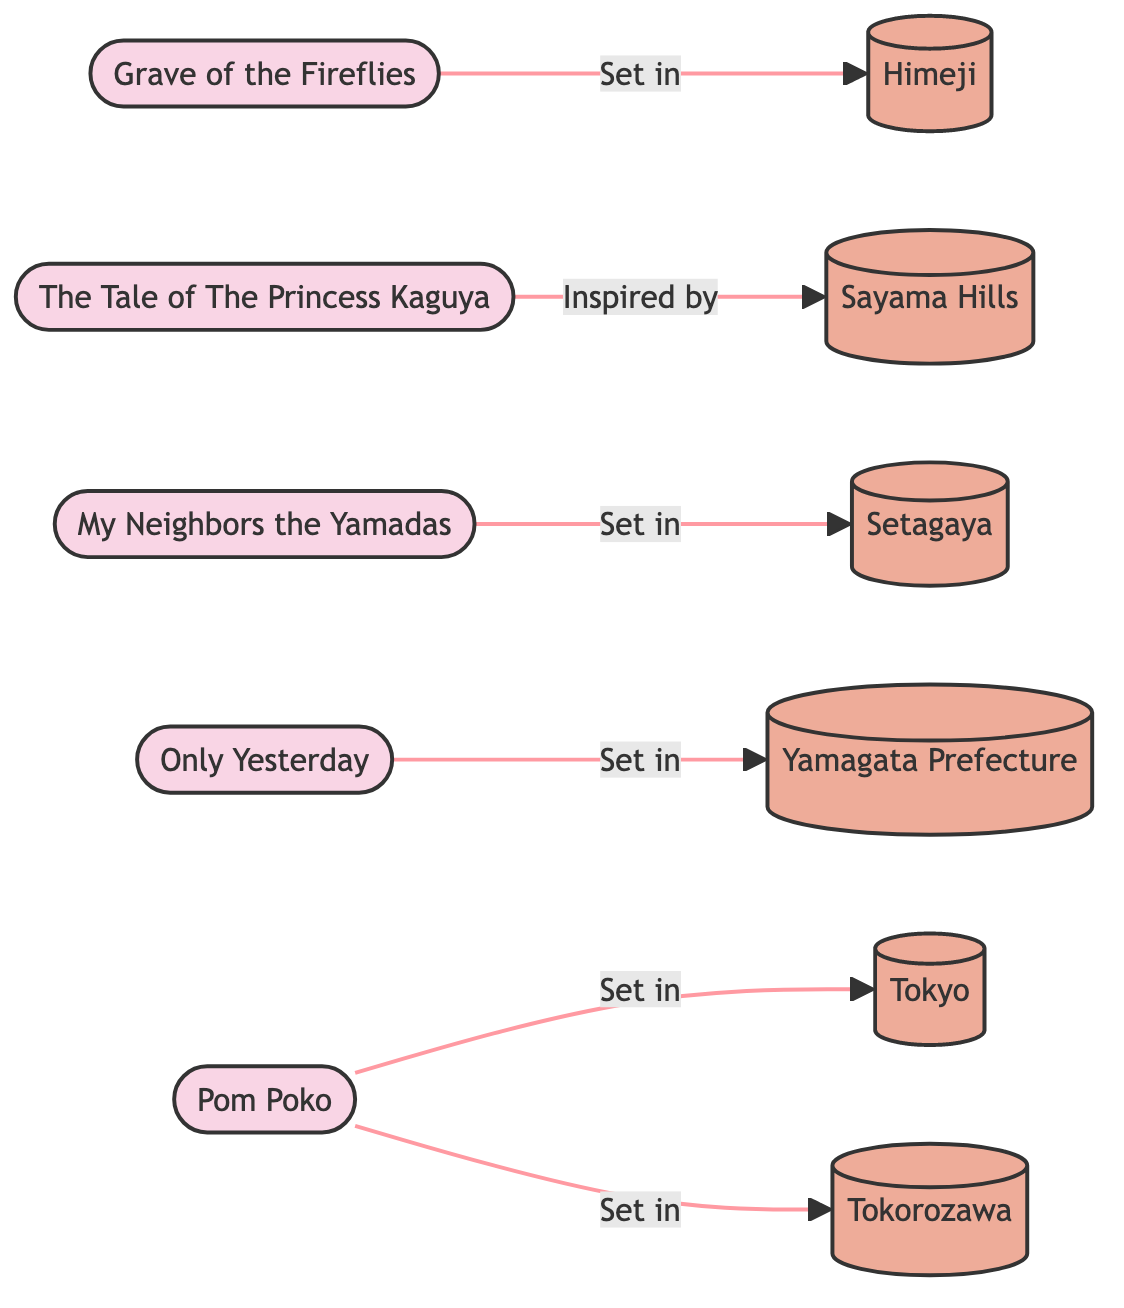What film is set in Himeji? The diagram indicates that "Grave of the Fireflies" is connected to "Himeji" with the label "Set in". Thus, it shows that Himeji is the location where this film takes place.
Answer: Grave of the Fireflies Which film is inspired by Sayama? According to the diagram, "The Tale of The Princess Kaguya" has a connection to "Sayama" with the label "Inspired by". This indicates that Sayama served as an inspiration for this film.
Answer: The Tale of The Princess Kaguya How many films are shown in the diagram? The diagram lists five films: "Grave of the Fireflies," "The Tale of The Princess Kaguya," "My Neighbors the Yamadas," "Only Yesterday," and "Pom Poko." Counting these gives a total of five films represented in the diagram.
Answer: 5 Which locations are depicted in the network diagram? The diagram includes six locations: "Himeji," "Yamagata," "Sayama Hills," "Setagaya," "Yamagata Prefecture," "Tokyo," and "Tokorozawa." By identifying and counting the location nodes, we find these seven distinct places.
Answer: Himeji, Sayama Hills, Setagaya, Yamagata Prefecture, Tokyo, Tokorozawa What is the relationship between Pom Poko and Tokorozawa? The diagram connects "Pom Poko" to "Tokorozawa" with the label "Set in". This indicates that the film is set in Tokorozawa, establishing a direct connection between the two nodes.
Answer: Set in Which film connects to the most distinct locations? "Pom Poko" is the film that connects to "Tokyo" and "Tokorozawa", making it associated with two distinct locations. This is more than any other film in the diagram, which connects to only one location each.
Answer: Pom Poko Is there a film connected to Yamagata Prefecture? Yes, the diagram shows that "Only Yesterday" has a direct connection to "Yamagata Prefecture" labeled "Set in". This indicates that this film takes place in Yamagata Prefecture.
Answer: Only Yesterday 